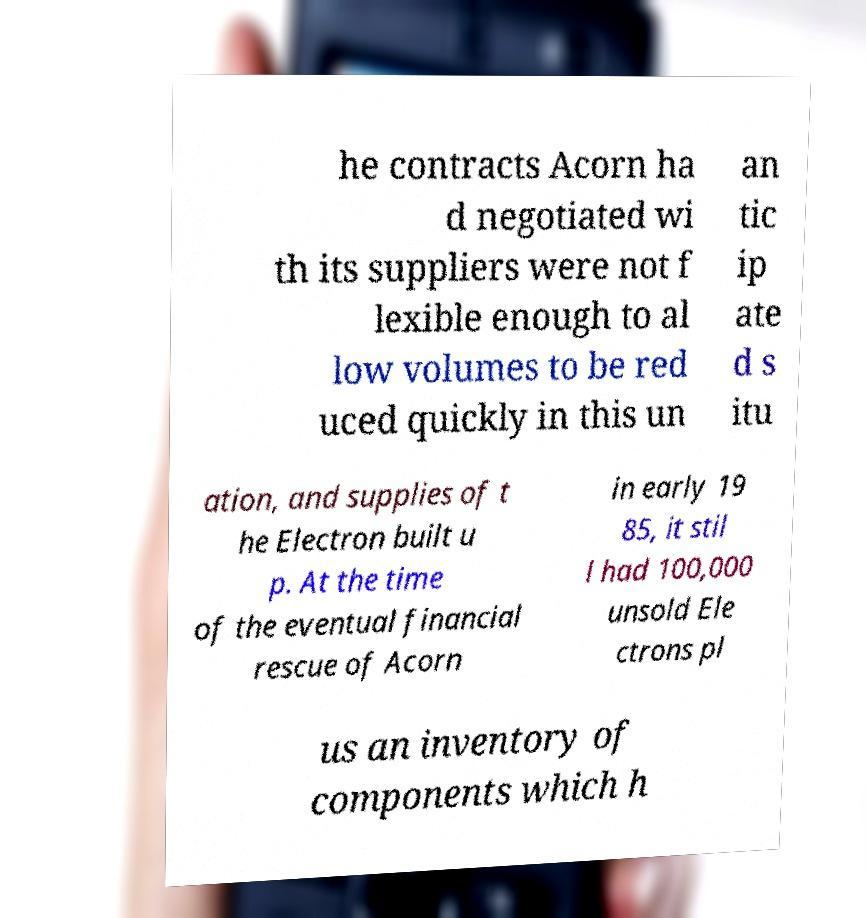For documentation purposes, I need the text within this image transcribed. Could you provide that? he contracts Acorn ha d negotiated wi th its suppliers were not f lexible enough to al low volumes to be red uced quickly in this un an tic ip ate d s itu ation, and supplies of t he Electron built u p. At the time of the eventual financial rescue of Acorn in early 19 85, it stil l had 100,000 unsold Ele ctrons pl us an inventory of components which h 